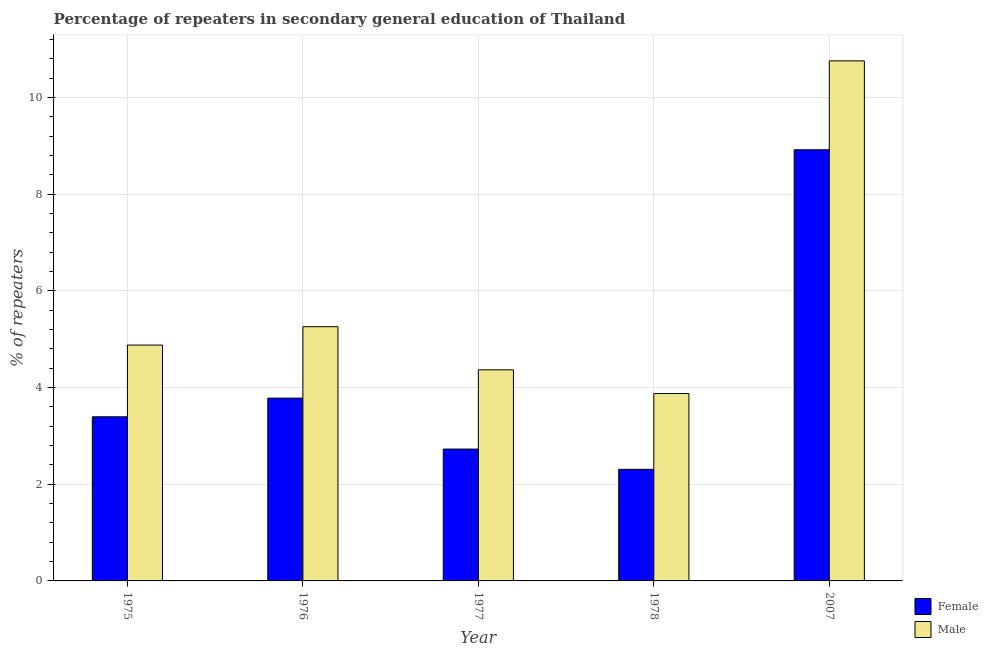How many different coloured bars are there?
Provide a succinct answer. 2. How many groups of bars are there?
Give a very brief answer. 5. Are the number of bars per tick equal to the number of legend labels?
Provide a short and direct response. Yes. How many bars are there on the 2nd tick from the left?
Your answer should be very brief. 2. How many bars are there on the 1st tick from the right?
Your answer should be compact. 2. What is the label of the 4th group of bars from the left?
Your response must be concise. 1978. In how many cases, is the number of bars for a given year not equal to the number of legend labels?
Offer a very short reply. 0. What is the percentage of male repeaters in 1978?
Make the answer very short. 3.88. Across all years, what is the maximum percentage of male repeaters?
Your answer should be very brief. 10.76. Across all years, what is the minimum percentage of female repeaters?
Give a very brief answer. 2.31. In which year was the percentage of male repeaters minimum?
Give a very brief answer. 1978. What is the total percentage of female repeaters in the graph?
Your answer should be compact. 21.13. What is the difference between the percentage of female repeaters in 1977 and that in 1978?
Your answer should be very brief. 0.42. What is the difference between the percentage of male repeaters in 1977 and the percentage of female repeaters in 2007?
Provide a succinct answer. -6.39. What is the average percentage of male repeaters per year?
Your answer should be very brief. 5.83. In the year 2007, what is the difference between the percentage of male repeaters and percentage of female repeaters?
Your answer should be very brief. 0. In how many years, is the percentage of female repeaters greater than 1.2000000000000002 %?
Give a very brief answer. 5. What is the ratio of the percentage of male repeaters in 1976 to that in 1977?
Provide a succinct answer. 1.2. Is the difference between the percentage of male repeaters in 1975 and 2007 greater than the difference between the percentage of female repeaters in 1975 and 2007?
Your answer should be very brief. No. What is the difference between the highest and the second highest percentage of female repeaters?
Offer a terse response. 5.14. What is the difference between the highest and the lowest percentage of female repeaters?
Provide a short and direct response. 6.61. What does the 2nd bar from the left in 1978 represents?
Offer a terse response. Male. What does the 2nd bar from the right in 2007 represents?
Keep it short and to the point. Female. How many bars are there?
Provide a succinct answer. 10. What is the difference between two consecutive major ticks on the Y-axis?
Keep it short and to the point. 2. Does the graph contain any zero values?
Offer a very short reply. No. Does the graph contain grids?
Offer a very short reply. Yes. What is the title of the graph?
Offer a very short reply. Percentage of repeaters in secondary general education of Thailand. Does "Export" appear as one of the legend labels in the graph?
Ensure brevity in your answer.  No. What is the label or title of the X-axis?
Make the answer very short. Year. What is the label or title of the Y-axis?
Your response must be concise. % of repeaters. What is the % of repeaters of Female in 1975?
Make the answer very short. 3.39. What is the % of repeaters in Male in 1975?
Your response must be concise. 4.88. What is the % of repeaters of Female in 1976?
Give a very brief answer. 3.78. What is the % of repeaters of Male in 1976?
Offer a terse response. 5.26. What is the % of repeaters in Female in 1977?
Keep it short and to the point. 2.73. What is the % of repeaters of Male in 1977?
Provide a short and direct response. 4.37. What is the % of repeaters in Female in 1978?
Provide a succinct answer. 2.31. What is the % of repeaters of Male in 1978?
Provide a succinct answer. 3.88. What is the % of repeaters of Female in 2007?
Provide a succinct answer. 8.92. What is the % of repeaters in Male in 2007?
Provide a succinct answer. 10.76. Across all years, what is the maximum % of repeaters of Female?
Your answer should be compact. 8.92. Across all years, what is the maximum % of repeaters in Male?
Offer a very short reply. 10.76. Across all years, what is the minimum % of repeaters of Female?
Ensure brevity in your answer.  2.31. Across all years, what is the minimum % of repeaters in Male?
Keep it short and to the point. 3.88. What is the total % of repeaters of Female in the graph?
Your answer should be very brief. 21.13. What is the total % of repeaters in Male in the graph?
Ensure brevity in your answer.  29.13. What is the difference between the % of repeaters in Female in 1975 and that in 1976?
Your response must be concise. -0.39. What is the difference between the % of repeaters in Male in 1975 and that in 1976?
Your response must be concise. -0.38. What is the difference between the % of repeaters of Female in 1975 and that in 1977?
Make the answer very short. 0.67. What is the difference between the % of repeaters in Male in 1975 and that in 1977?
Your answer should be very brief. 0.51. What is the difference between the % of repeaters in Female in 1975 and that in 1978?
Provide a short and direct response. 1.09. What is the difference between the % of repeaters in Female in 1975 and that in 2007?
Your response must be concise. -5.52. What is the difference between the % of repeaters of Male in 1975 and that in 2007?
Offer a terse response. -5.88. What is the difference between the % of repeaters of Female in 1976 and that in 1977?
Your answer should be very brief. 1.05. What is the difference between the % of repeaters of Male in 1976 and that in 1977?
Provide a short and direct response. 0.89. What is the difference between the % of repeaters in Female in 1976 and that in 1978?
Offer a very short reply. 1.47. What is the difference between the % of repeaters of Male in 1976 and that in 1978?
Give a very brief answer. 1.38. What is the difference between the % of repeaters of Female in 1976 and that in 2007?
Ensure brevity in your answer.  -5.14. What is the difference between the % of repeaters in Male in 1976 and that in 2007?
Provide a short and direct response. -5.5. What is the difference between the % of repeaters in Female in 1977 and that in 1978?
Keep it short and to the point. 0.42. What is the difference between the % of repeaters of Male in 1977 and that in 1978?
Offer a very short reply. 0.49. What is the difference between the % of repeaters in Female in 1977 and that in 2007?
Give a very brief answer. -6.19. What is the difference between the % of repeaters of Male in 1977 and that in 2007?
Your response must be concise. -6.39. What is the difference between the % of repeaters in Female in 1978 and that in 2007?
Make the answer very short. -6.61. What is the difference between the % of repeaters in Male in 1978 and that in 2007?
Give a very brief answer. -6.88. What is the difference between the % of repeaters of Female in 1975 and the % of repeaters of Male in 1976?
Your answer should be compact. -1.86. What is the difference between the % of repeaters of Female in 1975 and the % of repeaters of Male in 1977?
Offer a terse response. -0.97. What is the difference between the % of repeaters of Female in 1975 and the % of repeaters of Male in 1978?
Ensure brevity in your answer.  -0.48. What is the difference between the % of repeaters in Female in 1975 and the % of repeaters in Male in 2007?
Your answer should be compact. -7.36. What is the difference between the % of repeaters in Female in 1976 and the % of repeaters in Male in 1977?
Your answer should be compact. -0.59. What is the difference between the % of repeaters of Female in 1976 and the % of repeaters of Male in 1978?
Provide a short and direct response. -0.1. What is the difference between the % of repeaters of Female in 1976 and the % of repeaters of Male in 2007?
Your answer should be very brief. -6.98. What is the difference between the % of repeaters of Female in 1977 and the % of repeaters of Male in 1978?
Give a very brief answer. -1.15. What is the difference between the % of repeaters of Female in 1977 and the % of repeaters of Male in 2007?
Your answer should be compact. -8.03. What is the difference between the % of repeaters in Female in 1978 and the % of repeaters in Male in 2007?
Your response must be concise. -8.45. What is the average % of repeaters of Female per year?
Ensure brevity in your answer.  4.23. What is the average % of repeaters of Male per year?
Provide a short and direct response. 5.83. In the year 1975, what is the difference between the % of repeaters of Female and % of repeaters of Male?
Ensure brevity in your answer.  -1.48. In the year 1976, what is the difference between the % of repeaters in Female and % of repeaters in Male?
Give a very brief answer. -1.48. In the year 1977, what is the difference between the % of repeaters in Female and % of repeaters in Male?
Provide a succinct answer. -1.64. In the year 1978, what is the difference between the % of repeaters in Female and % of repeaters in Male?
Your response must be concise. -1.57. In the year 2007, what is the difference between the % of repeaters of Female and % of repeaters of Male?
Ensure brevity in your answer.  -1.84. What is the ratio of the % of repeaters in Female in 1975 to that in 1976?
Offer a terse response. 0.9. What is the ratio of the % of repeaters of Male in 1975 to that in 1976?
Give a very brief answer. 0.93. What is the ratio of the % of repeaters of Female in 1975 to that in 1977?
Make the answer very short. 1.24. What is the ratio of the % of repeaters of Male in 1975 to that in 1977?
Your answer should be very brief. 1.12. What is the ratio of the % of repeaters in Female in 1975 to that in 1978?
Your answer should be compact. 1.47. What is the ratio of the % of repeaters of Male in 1975 to that in 1978?
Keep it short and to the point. 1.26. What is the ratio of the % of repeaters of Female in 1975 to that in 2007?
Keep it short and to the point. 0.38. What is the ratio of the % of repeaters of Male in 1975 to that in 2007?
Your answer should be very brief. 0.45. What is the ratio of the % of repeaters of Female in 1976 to that in 1977?
Your answer should be very brief. 1.39. What is the ratio of the % of repeaters in Male in 1976 to that in 1977?
Offer a very short reply. 1.2. What is the ratio of the % of repeaters of Female in 1976 to that in 1978?
Your answer should be very brief. 1.64. What is the ratio of the % of repeaters of Male in 1976 to that in 1978?
Make the answer very short. 1.36. What is the ratio of the % of repeaters of Female in 1976 to that in 2007?
Offer a terse response. 0.42. What is the ratio of the % of repeaters of Male in 1976 to that in 2007?
Keep it short and to the point. 0.49. What is the ratio of the % of repeaters in Female in 1977 to that in 1978?
Your answer should be very brief. 1.18. What is the ratio of the % of repeaters of Male in 1977 to that in 1978?
Give a very brief answer. 1.13. What is the ratio of the % of repeaters of Female in 1977 to that in 2007?
Offer a terse response. 0.31. What is the ratio of the % of repeaters in Male in 1977 to that in 2007?
Your answer should be very brief. 0.41. What is the ratio of the % of repeaters in Female in 1978 to that in 2007?
Keep it short and to the point. 0.26. What is the ratio of the % of repeaters of Male in 1978 to that in 2007?
Give a very brief answer. 0.36. What is the difference between the highest and the second highest % of repeaters in Female?
Your answer should be compact. 5.14. What is the difference between the highest and the second highest % of repeaters in Male?
Your response must be concise. 5.5. What is the difference between the highest and the lowest % of repeaters in Female?
Your answer should be compact. 6.61. What is the difference between the highest and the lowest % of repeaters in Male?
Your answer should be compact. 6.88. 